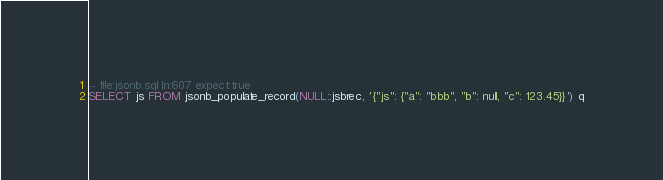Convert code to text. <code><loc_0><loc_0><loc_500><loc_500><_SQL_>-- file:jsonb.sql ln:607 expect:true
SELECT js FROM jsonb_populate_record(NULL::jsbrec, '{"js": {"a": "bbb", "b": null, "c": 123.45}}') q
</code> 